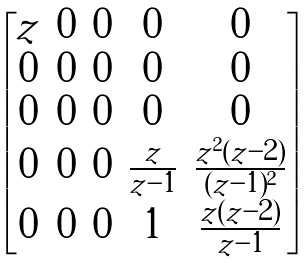Convert formula to latex. <formula><loc_0><loc_0><loc_500><loc_500>\begin{bmatrix} z & 0 & 0 & 0 & 0 \\ 0 & 0 & 0 & 0 & 0 \\ 0 & 0 & 0 & 0 & 0 \\ 0 & 0 & 0 & \frac { z } { z - 1 } & \frac { z ^ { 2 } ( z - 2 ) } { ( z - 1 ) ^ { 2 } } \\ 0 & 0 & 0 & 1 & \frac { z ( z - 2 ) } { z - 1 } \end{bmatrix}</formula> 